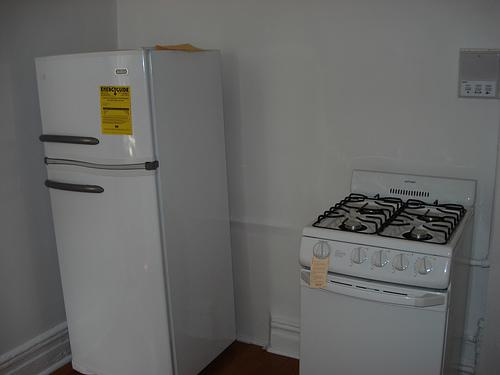Question: where is the cooker?
Choices:
A. On the floor.
B. By the sink.
C. Next to the refrigerator.
D. Next to the dish washer.
Answer with the letter. Answer: C Question: what color is the wall?
Choices:
A. Blue.
B. White.
C. Gray.
D. Yellow.
Answer with the letter. Answer: B Question: who is in the photo?
Choices:
A. Five people.
B. No one.
C. Two women.
D. Three children.
Answer with the letter. Answer: B Question: what is next to the wall on the left?
Choices:
A. A coat.
B. A painting.
C. A refrigerator.
D. A book.
Answer with the letter. Answer: C 